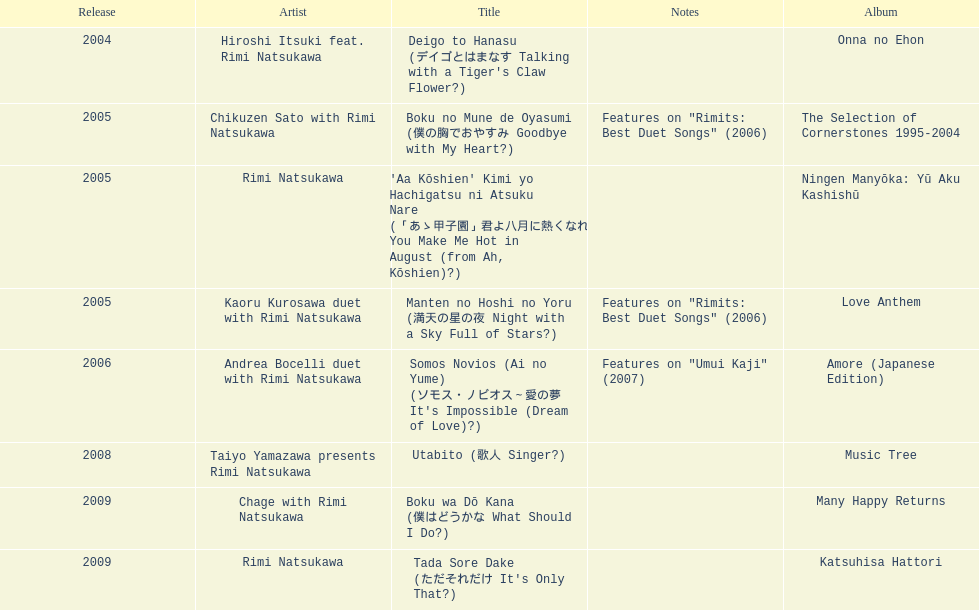Which was not unveiled in 2004, onna no ehon or music tree? Music Tree. 